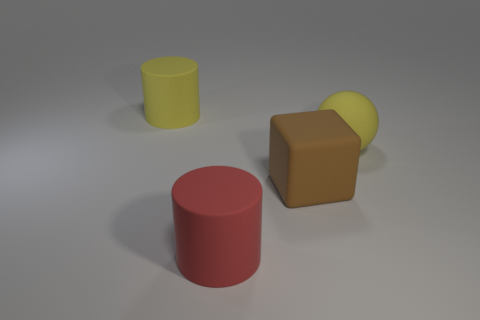There is a rubber object to the right of the brown rubber cube; does it have the same size as the big brown matte thing?
Your answer should be very brief. Yes. Are there any matte objects that have the same color as the ball?
Make the answer very short. Yes. Are there more large matte objects that are in front of the big yellow sphere than big red rubber cylinders that are right of the large brown rubber cube?
Your answer should be compact. Yes. What number of other objects are there of the same material as the large yellow cylinder?
Give a very brief answer. 3. The large red thing is what shape?
Give a very brief answer. Cylinder. Is the number of big cylinders behind the red cylinder greater than the number of tiny brown metallic objects?
Offer a terse response. Yes. Is there any other thing that has the same shape as the brown thing?
Your answer should be compact. No. What is the color of the other large rubber thing that is the same shape as the red rubber thing?
Provide a succinct answer. Yellow. What is the shape of the object to the right of the cube?
Keep it short and to the point. Sphere. There is a yellow rubber cylinder; are there any matte objects in front of it?
Keep it short and to the point. Yes. 